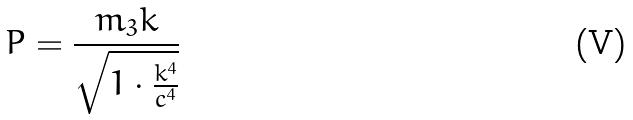<formula> <loc_0><loc_0><loc_500><loc_500>P = \frac { m _ { 3 } k } { \sqrt { 1 \cdot \frac { k ^ { 4 } } { c ^ { 4 } } } }</formula> 